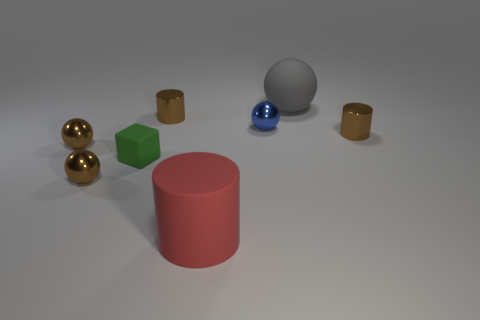Subtract 1 balls. How many balls are left? 3 Subtract all blue spheres. How many spheres are left? 3 Subtract all red spheres. Subtract all green cylinders. How many spheres are left? 4 Add 2 tiny blue metal cubes. How many objects exist? 10 Subtract all cubes. How many objects are left? 7 Subtract 1 brown spheres. How many objects are left? 7 Subtract all small brown blocks. Subtract all red objects. How many objects are left? 7 Add 4 green objects. How many green objects are left? 5 Add 3 big red objects. How many big red objects exist? 4 